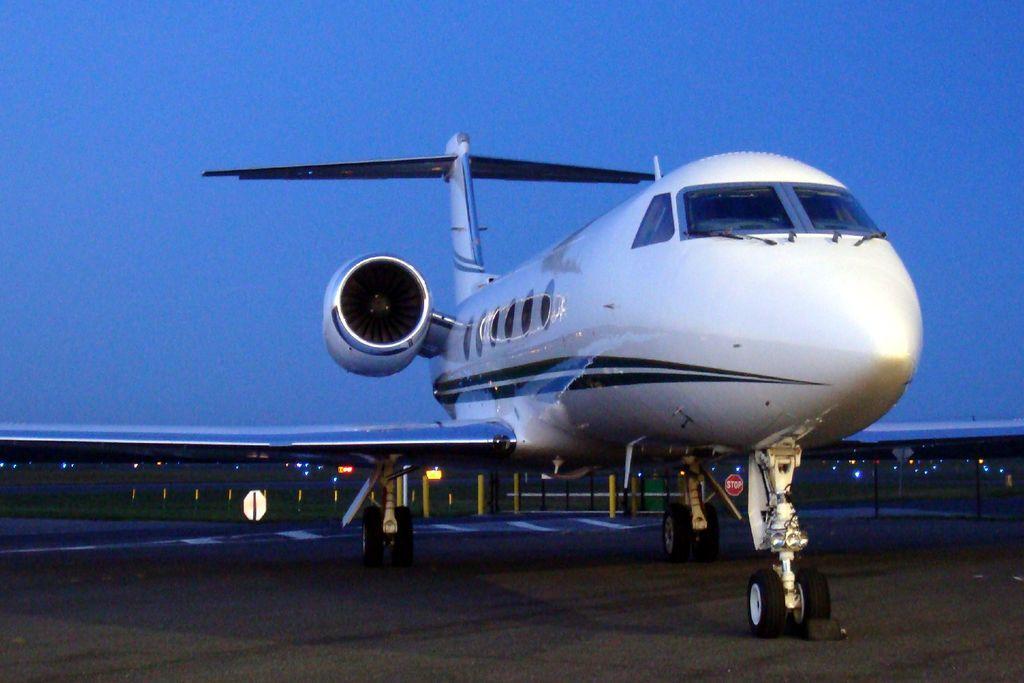In one or two sentences, can you explain what this image depicts? In this picture we can see an airplane on the ground. In the background we can see poles, fence, lights, some objects and the sky. 